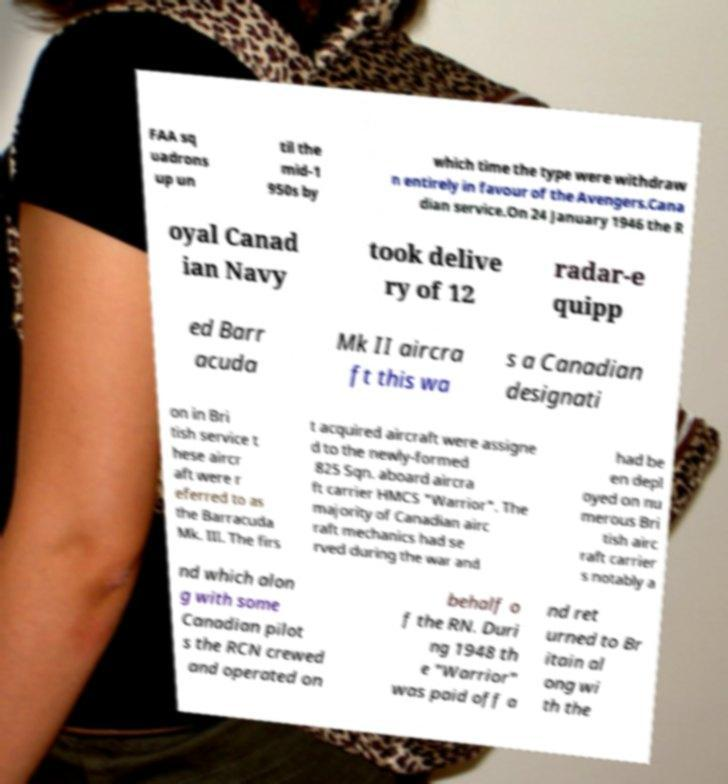What messages or text are displayed in this image? I need them in a readable, typed format. FAA sq uadrons up un til the mid-1 950s by which time the type were withdraw n entirely in favour of the Avengers.Cana dian service.On 24 January 1946 the R oyal Canad ian Navy took delive ry of 12 radar-e quipp ed Barr acuda Mk II aircra ft this wa s a Canadian designati on in Bri tish service t hese aircr aft were r eferred to as the Barracuda Mk. III. The firs t acquired aircraft were assigne d to the newly-formed 825 Sqn. aboard aircra ft carrier HMCS "Warrior". The majority of Canadian airc raft mechanics had se rved during the war and had be en depl oyed on nu merous Bri tish airc raft carrier s notably a nd which alon g with some Canadian pilot s the RCN crewed and operated on behalf o f the RN. Duri ng 1948 th e "Warrior" was paid off a nd ret urned to Br itain al ong wi th the 